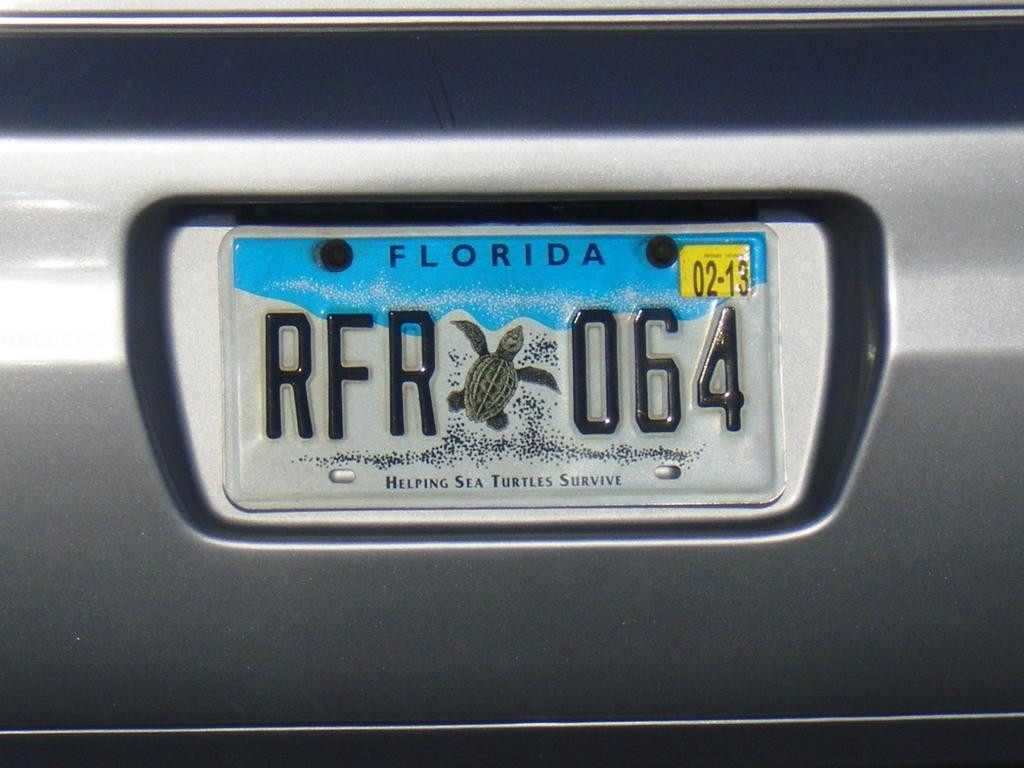<image>
Summarize the visual content of the image. A close up image of a Florida license plate with the code RFR064. 